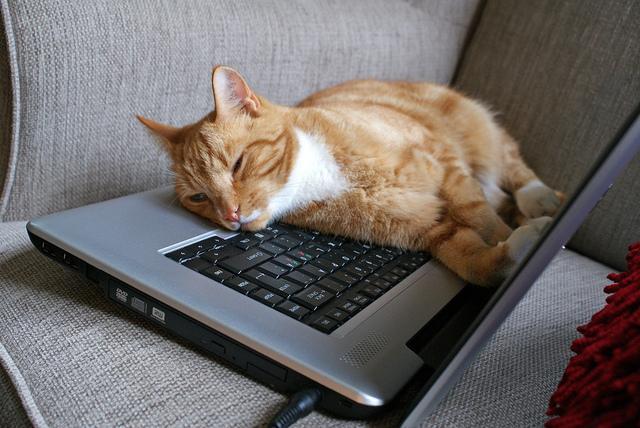How many zebras are there?
Give a very brief answer. 0. 